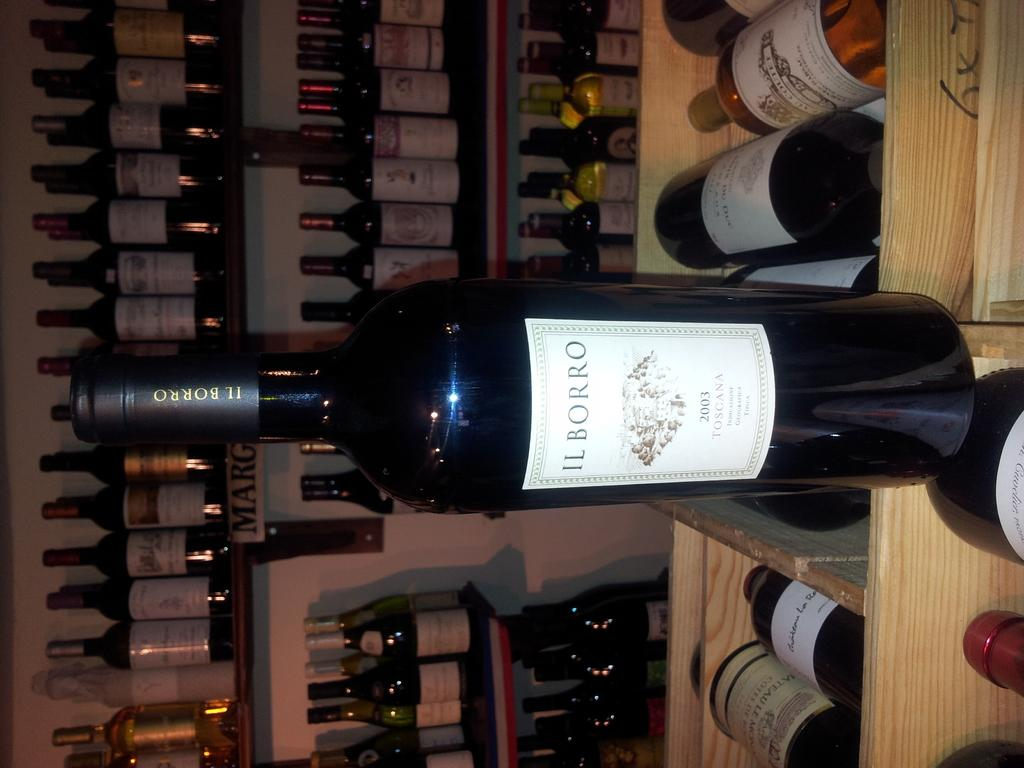<image>
Describe the image concisely. Bottle of black alcohol which says Ilborro on the label. 